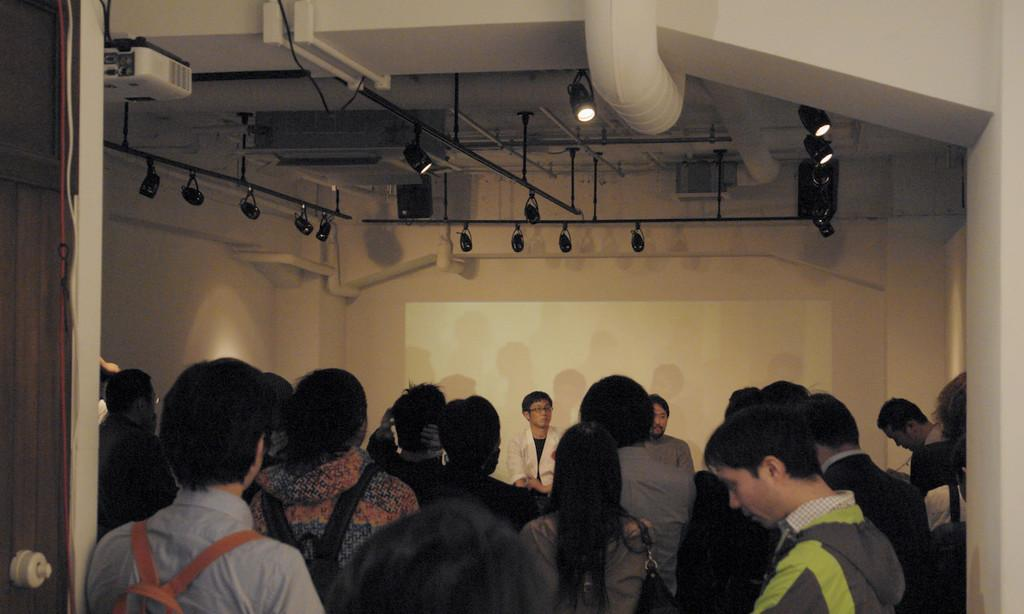What can be seen in the image involving people? There are people standing in the image. What type of structure is present in the image? There is a wall in the image. What is visible at the top of the image? Lights are visible at the top of the image. What type of object can be seen in the image related to air circulation? There is a duct in the image. What device is present in the image for displaying visuals? A projector is present in the image. Can you tell me how many people are jumping in the image? There is no indication of anyone jumping in the image; the people are standing. What type of coastline can be seen in the image? There is no coastline present in the image. 